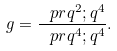Convert formula to latex. <formula><loc_0><loc_0><loc_500><loc_500>g = \frac { \ p r { q ^ { 2 } ; q ^ { 4 } } } { \ p r { q ^ { 4 } ; q ^ { 4 } } } .</formula> 